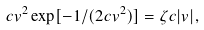Convert formula to latex. <formula><loc_0><loc_0><loc_500><loc_500>c v ^ { 2 } \exp [ - 1 / ( 2 c v ^ { 2 } ) ] = \zeta c | v | ,</formula> 